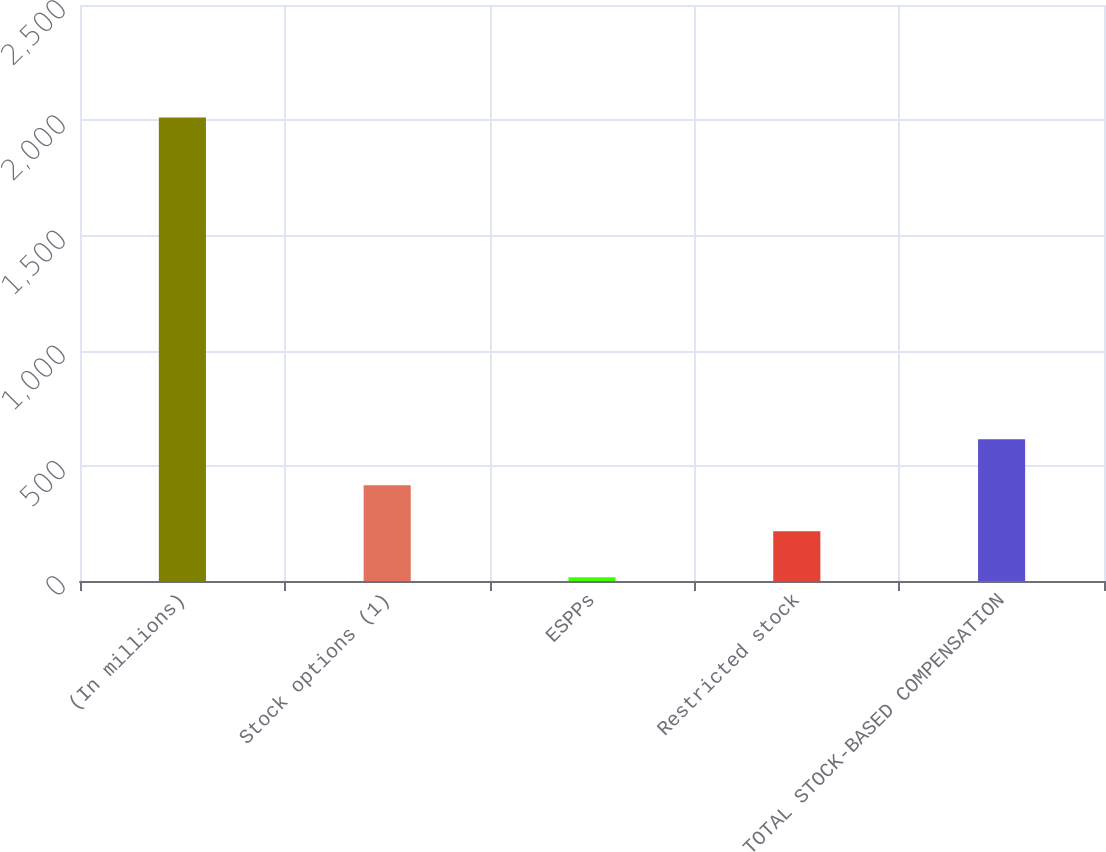Convert chart. <chart><loc_0><loc_0><loc_500><loc_500><bar_chart><fcel>(In millions)<fcel>Stock options (1)<fcel>ESPPs<fcel>Restricted stock<fcel>TOTAL STOCK-BASED COMPENSATION<nl><fcel>2012<fcel>415.2<fcel>16<fcel>215.6<fcel>614.8<nl></chart> 